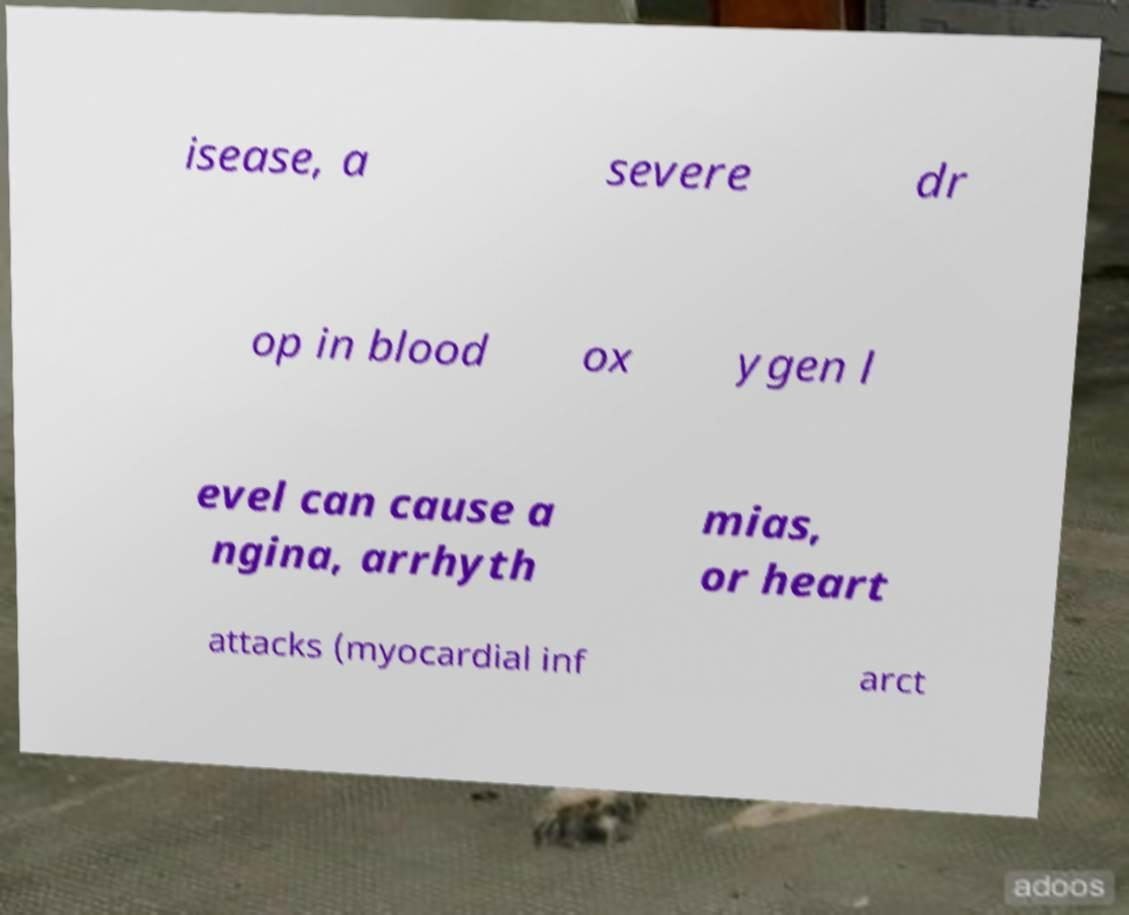There's text embedded in this image that I need extracted. Can you transcribe it verbatim? isease, a severe dr op in blood ox ygen l evel can cause a ngina, arrhyth mias, or heart attacks (myocardial inf arct 